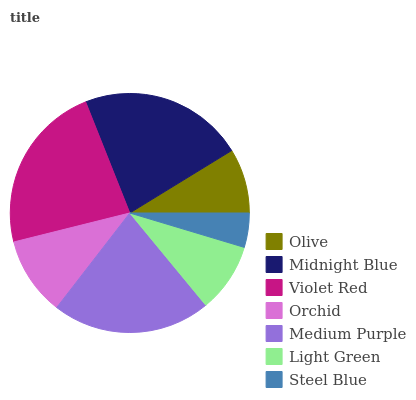Is Steel Blue the minimum?
Answer yes or no. Yes. Is Violet Red the maximum?
Answer yes or no. Yes. Is Midnight Blue the minimum?
Answer yes or no. No. Is Midnight Blue the maximum?
Answer yes or no. No. Is Midnight Blue greater than Olive?
Answer yes or no. Yes. Is Olive less than Midnight Blue?
Answer yes or no. Yes. Is Olive greater than Midnight Blue?
Answer yes or no. No. Is Midnight Blue less than Olive?
Answer yes or no. No. Is Orchid the high median?
Answer yes or no. Yes. Is Orchid the low median?
Answer yes or no. Yes. Is Olive the high median?
Answer yes or no. No. Is Light Green the low median?
Answer yes or no. No. 